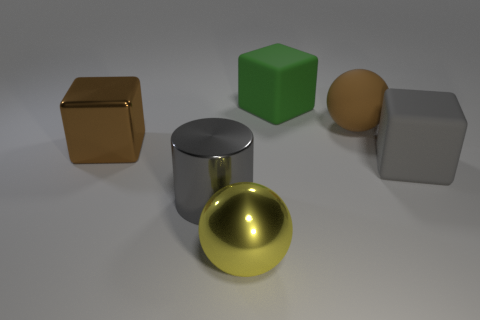What number of big blocks are on the right side of the large gray metallic thing?
Make the answer very short. 2. Are there any cylinders that have the same material as the yellow thing?
Your response must be concise. Yes. What shape is the big thing that is the same color as the metal cylinder?
Give a very brief answer. Cube. There is a rubber cube behind the big metal block; what color is it?
Your answer should be very brief. Green. Are there the same number of big yellow objects left of the cylinder and big brown shiny cubes behind the brown shiny block?
Provide a short and direct response. Yes. The large brown thing that is behind the cube on the left side of the yellow object is made of what material?
Your answer should be compact. Rubber. How many objects are matte objects or large things in front of the large gray matte cube?
Provide a succinct answer. 5. What size is the gray thing that is the same material as the big yellow sphere?
Provide a succinct answer. Large. Is the number of green rubber objects behind the gray metal thing greater than the number of small yellow shiny spheres?
Give a very brief answer. Yes. What is the size of the object that is both on the left side of the gray matte cube and on the right side of the green matte cube?
Offer a terse response. Large. 